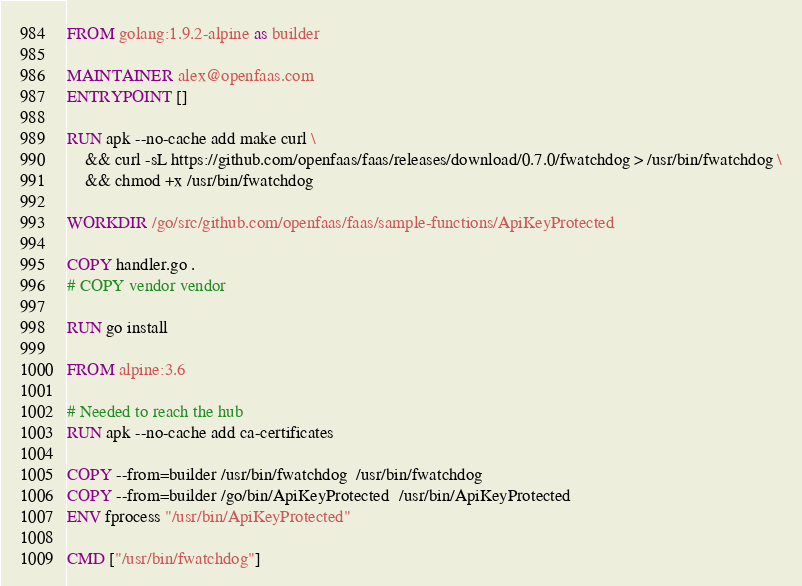Convert code to text. <code><loc_0><loc_0><loc_500><loc_500><_Dockerfile_>FROM golang:1.9.2-alpine as builder

MAINTAINER alex@openfaas.com
ENTRYPOINT []

RUN apk --no-cache add make curl \
    && curl -sL https://github.com/openfaas/faas/releases/download/0.7.0/fwatchdog > /usr/bin/fwatchdog \
    && chmod +x /usr/bin/fwatchdog

WORKDIR /go/src/github.com/openfaas/faas/sample-functions/ApiKeyProtected

COPY handler.go .
# COPY vendor vendor

RUN go install

FROM alpine:3.6

# Needed to reach the hub
RUN apk --no-cache add ca-certificates 

COPY --from=builder /usr/bin/fwatchdog  /usr/bin/fwatchdog
COPY --from=builder /go/bin/ApiKeyProtected  /usr/bin/ApiKeyProtected
ENV fprocess "/usr/bin/ApiKeyProtected"

CMD ["/usr/bin/fwatchdog"]
</code> 